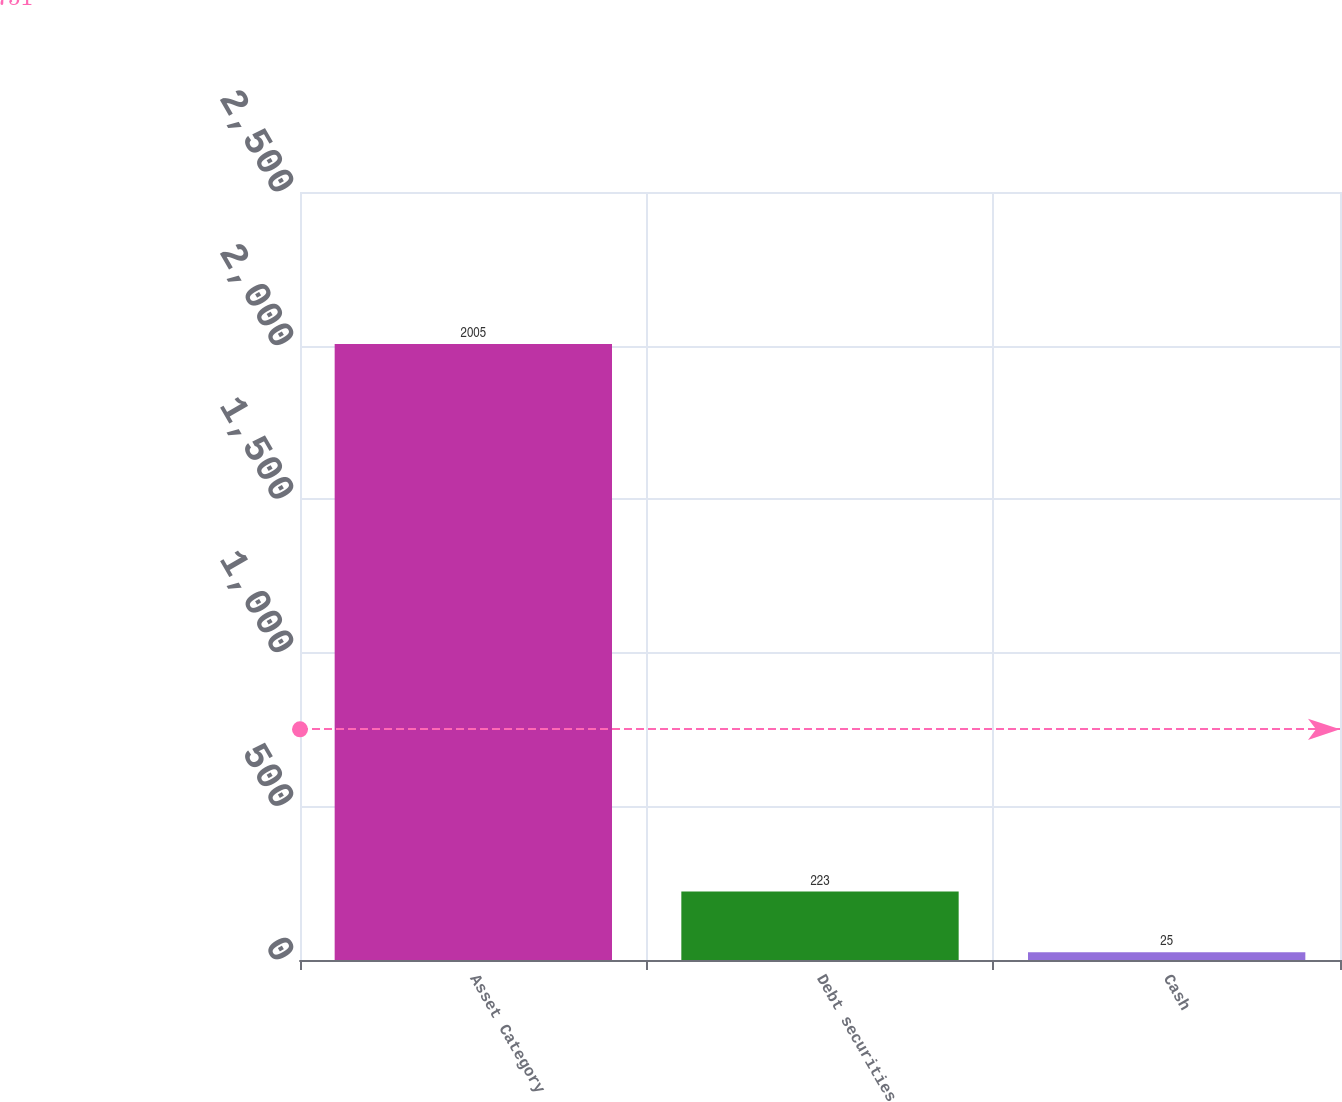<chart> <loc_0><loc_0><loc_500><loc_500><bar_chart><fcel>Asset Category<fcel>Debt securities<fcel>Cash<nl><fcel>2005<fcel>223<fcel>25<nl></chart> 